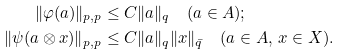Convert formula to latex. <formula><loc_0><loc_0><loc_500><loc_500>\| \varphi ( a ) \| _ { p , p } & \leq C \| a \| _ { q } \quad ( a \in A ) ; \\ \| \psi ( a \otimes x ) \| _ { p , p } & \leq C \| a \| _ { q } \| x \| _ { \bar { q } } \quad ( a \in A , \, x \in X ) .</formula> 